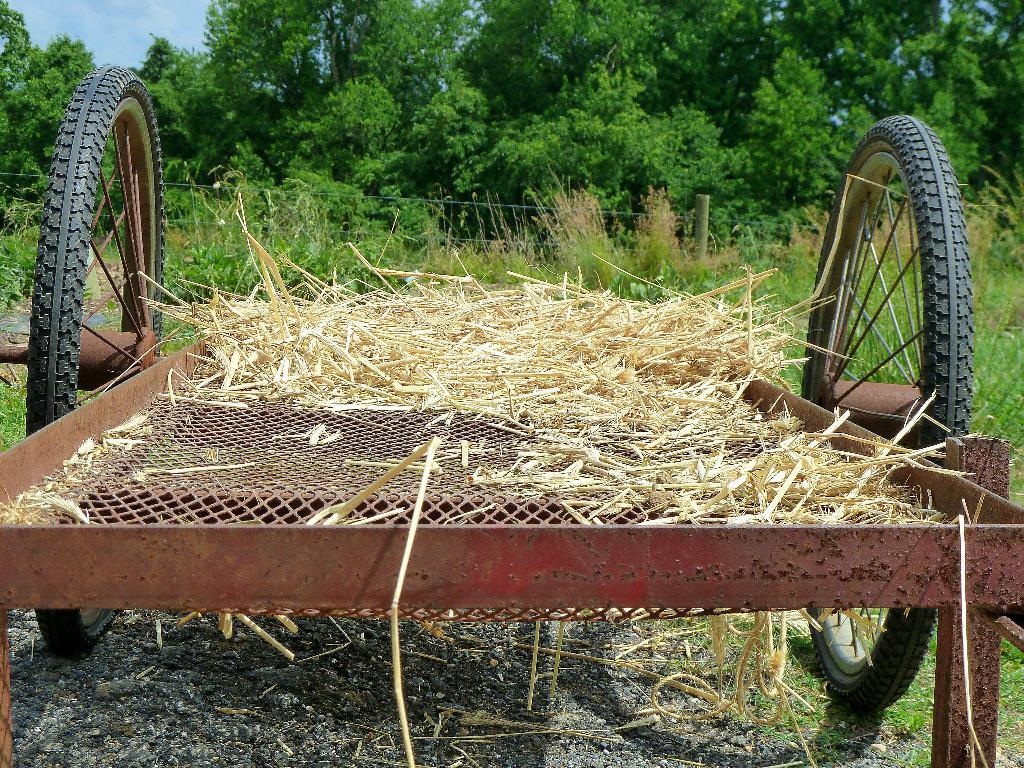What is the main subject of the image? The main subject of the image is a chariot. What is the ground cover in front of the chariot? Dry grass is present in front of the chariot. What type of material is used for the grill on the chariot? An iron grill is placed on the chariot. What type of vegetation can be seen behind the chariot? There are many green trees visible behind the chariot. What language is spoken by the people in the image? There are no people visible in the image, so it is not possible to determine the language spoken by them. 